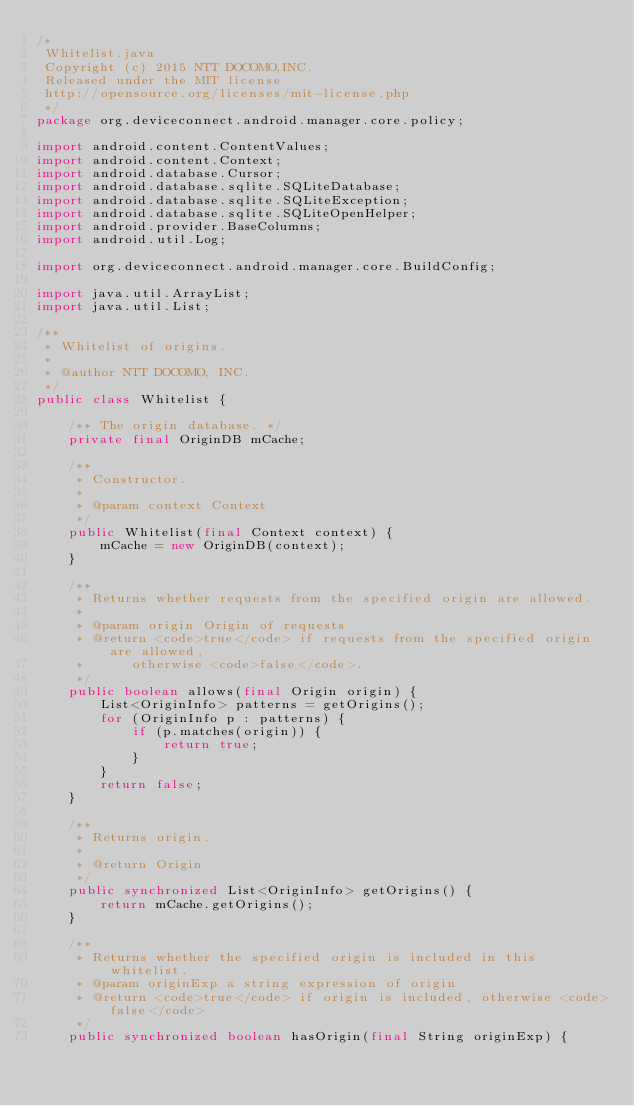<code> <loc_0><loc_0><loc_500><loc_500><_Java_>/*
 Whitelist.java
 Copyright (c) 2015 NTT DOCOMO,INC.
 Released under the MIT license
 http://opensource.org/licenses/mit-license.php
 */
package org.deviceconnect.android.manager.core.policy;

import android.content.ContentValues;
import android.content.Context;
import android.database.Cursor;
import android.database.sqlite.SQLiteDatabase;
import android.database.sqlite.SQLiteException;
import android.database.sqlite.SQLiteOpenHelper;
import android.provider.BaseColumns;
import android.util.Log;

import org.deviceconnect.android.manager.core.BuildConfig;

import java.util.ArrayList;
import java.util.List;

/**
 * Whitelist of origins.
 * 
 * @author NTT DOCOMO, INC.
 */
public class Whitelist {

    /** The origin database. */
    private final OriginDB mCache;

    /**
     * Constructor.
     * 
     * @param context Context
     */
    public Whitelist(final Context context) {
        mCache = new OriginDB(context);
    }

    /**
     * Returns whether requests from the specified origin are allowed.
     * 
     * @param origin Origin of requests
     * @return <code>true</code> if requests from the specified origin are allowed, 
     *      otherwise <code>false</code>.
     */
    public boolean allows(final Origin origin) {
        List<OriginInfo> patterns = getOrigins();
        for (OriginInfo p : patterns) {
            if (p.matches(origin)) {
                return true;
            }
        }
        return false;
    }

    /**
     * Returns origin.
     * 
     * @return Origin
     */
    public synchronized List<OriginInfo> getOrigins() {
        return mCache.getOrigins();
    }

    /**
     * Returns whether the specified origin is included in this whitelist.
     * @param originExp a string expression of origin
     * @return <code>true</code> if origin is included, otherwise <code>false</code>
     */
    public synchronized boolean hasOrigin(final String originExp) {</code> 